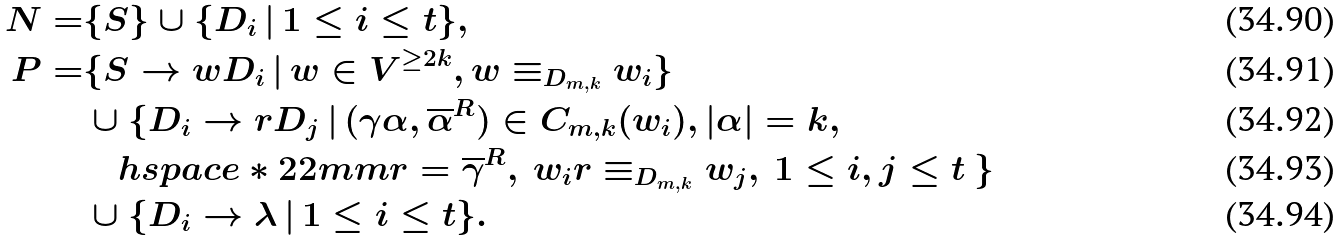<formula> <loc_0><loc_0><loc_500><loc_500>N = & \{ S \} \cup \{ D _ { i } \, | \, 1 \leq i \leq t \} , \\ P = & \{ S \rightarrow w D _ { i } \, | \, w \in V ^ { \geq 2 k } , w \equiv _ { D _ { m , k } } w _ { i } \} \\ & \cup \{ D _ { i } \rightarrow r D _ { j } \, | \, ( \gamma \alpha , \overline { \alpha } ^ { R } ) \in C _ { m , k } ( w _ { i } ) , | \alpha | = k , \\ & \quad h s p a c e * { 2 2 m m } r = \overline { \gamma } ^ { R } , \ w _ { i } r \equiv _ { D _ { m , k } } w _ { j } , \ 1 \leq i , j \leq t \ \} \\ & \cup \{ D _ { i } \rightarrow \lambda \, | \, 1 \leq i \leq t \} .</formula> 